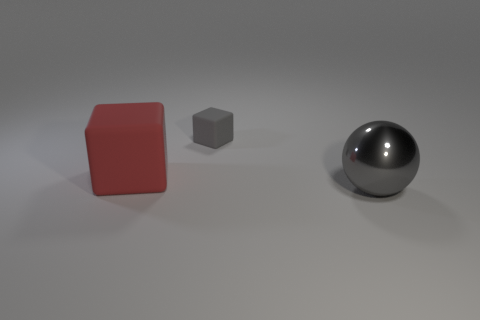Add 3 brown metallic spheres. How many objects exist? 6 Subtract all cubes. How many objects are left? 1 Subtract all tiny things. Subtract all big red matte blocks. How many objects are left? 1 Add 2 small gray rubber blocks. How many small gray rubber blocks are left? 3 Add 3 large gray balls. How many large gray balls exist? 4 Subtract 0 blue cylinders. How many objects are left? 3 